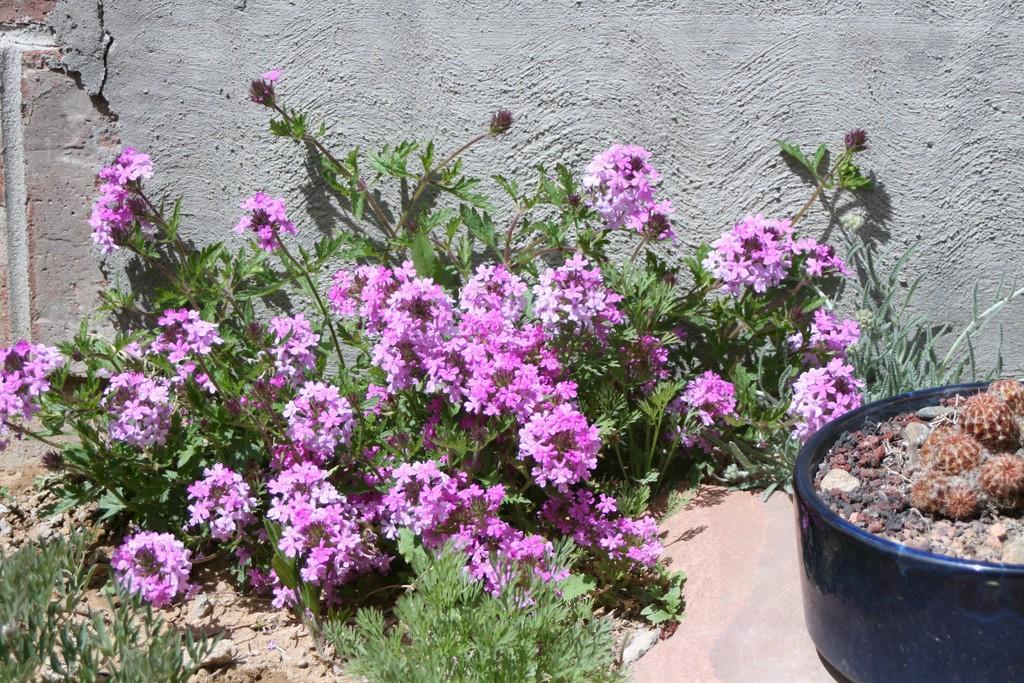Could you give a brief overview of what you see in this image? These are the plants with violet flowers. This looks like a flower pot with a cactus plant in it. Here is the wall. 